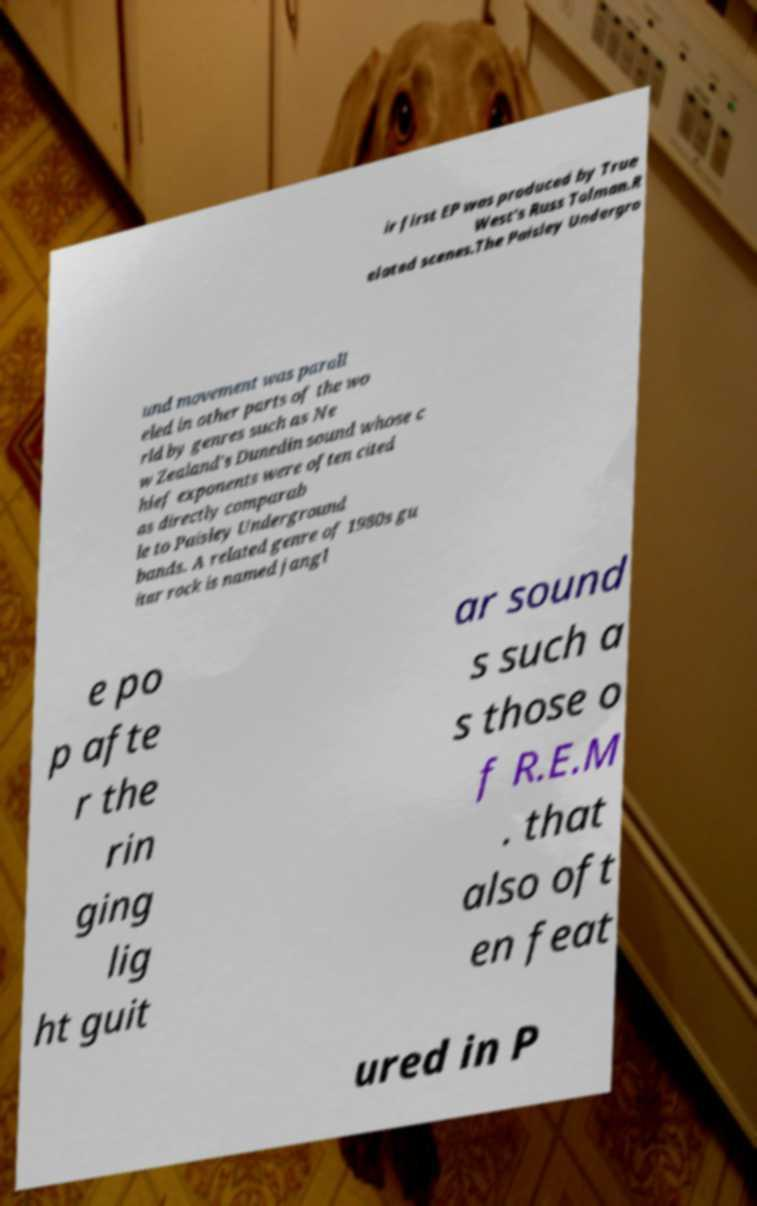For documentation purposes, I need the text within this image transcribed. Could you provide that? ir first EP was produced by True West's Russ Tolman.R elated scenes.The Paisley Undergro und movement was parall eled in other parts of the wo rld by genres such as Ne w Zealand's Dunedin sound whose c hief exponents were often cited as directly comparab le to Paisley Underground bands. A related genre of 1980s gu itar rock is named jangl e po p afte r the rin ging lig ht guit ar sound s such a s those o f R.E.M . that also oft en feat ured in P 